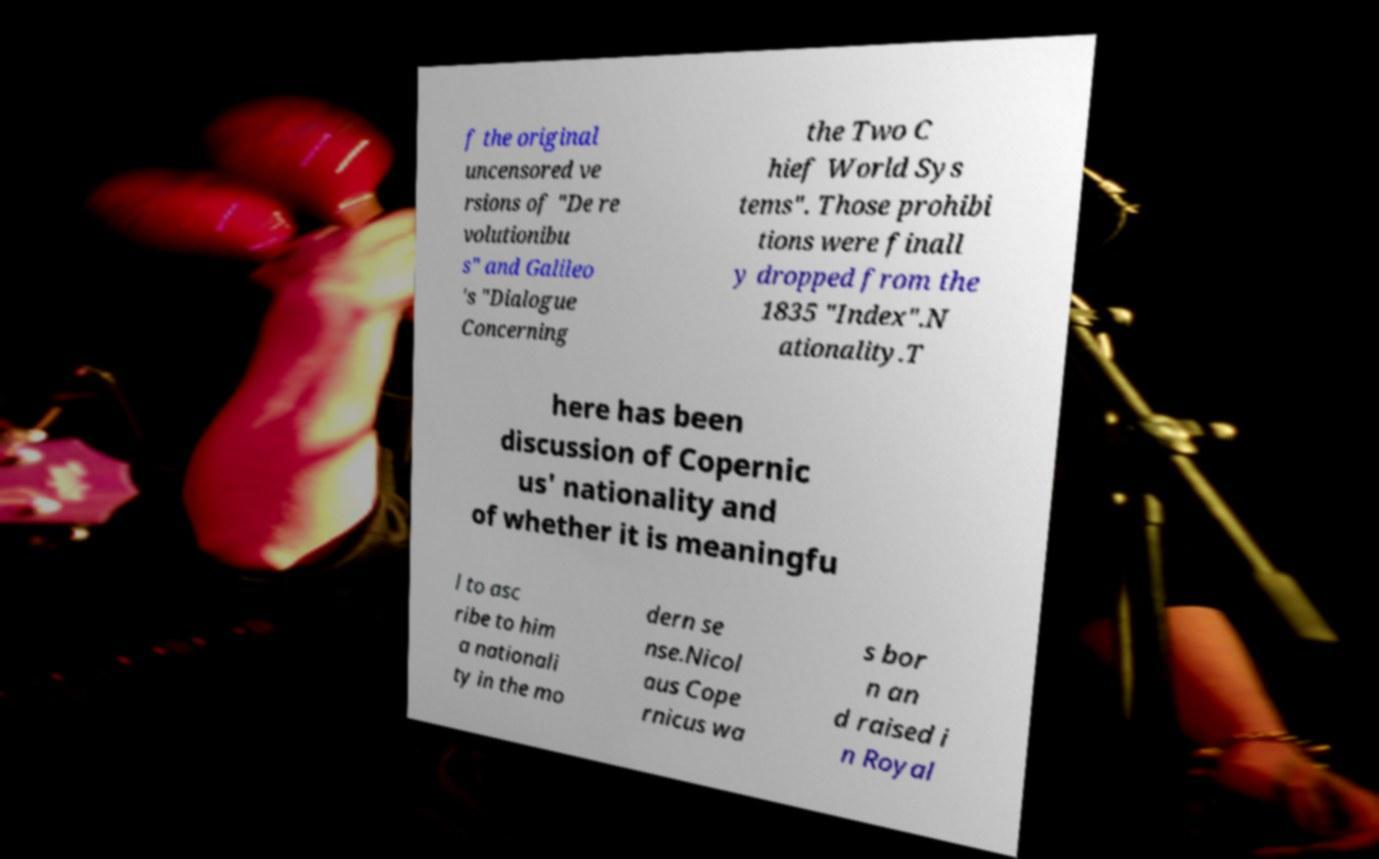Could you assist in decoding the text presented in this image and type it out clearly? f the original uncensored ve rsions of "De re volutionibu s" and Galileo 's "Dialogue Concerning the Two C hief World Sys tems". Those prohibi tions were finall y dropped from the 1835 "Index".N ationality.T here has been discussion of Copernic us' nationality and of whether it is meaningfu l to asc ribe to him a nationali ty in the mo dern se nse.Nicol aus Cope rnicus wa s bor n an d raised i n Royal 